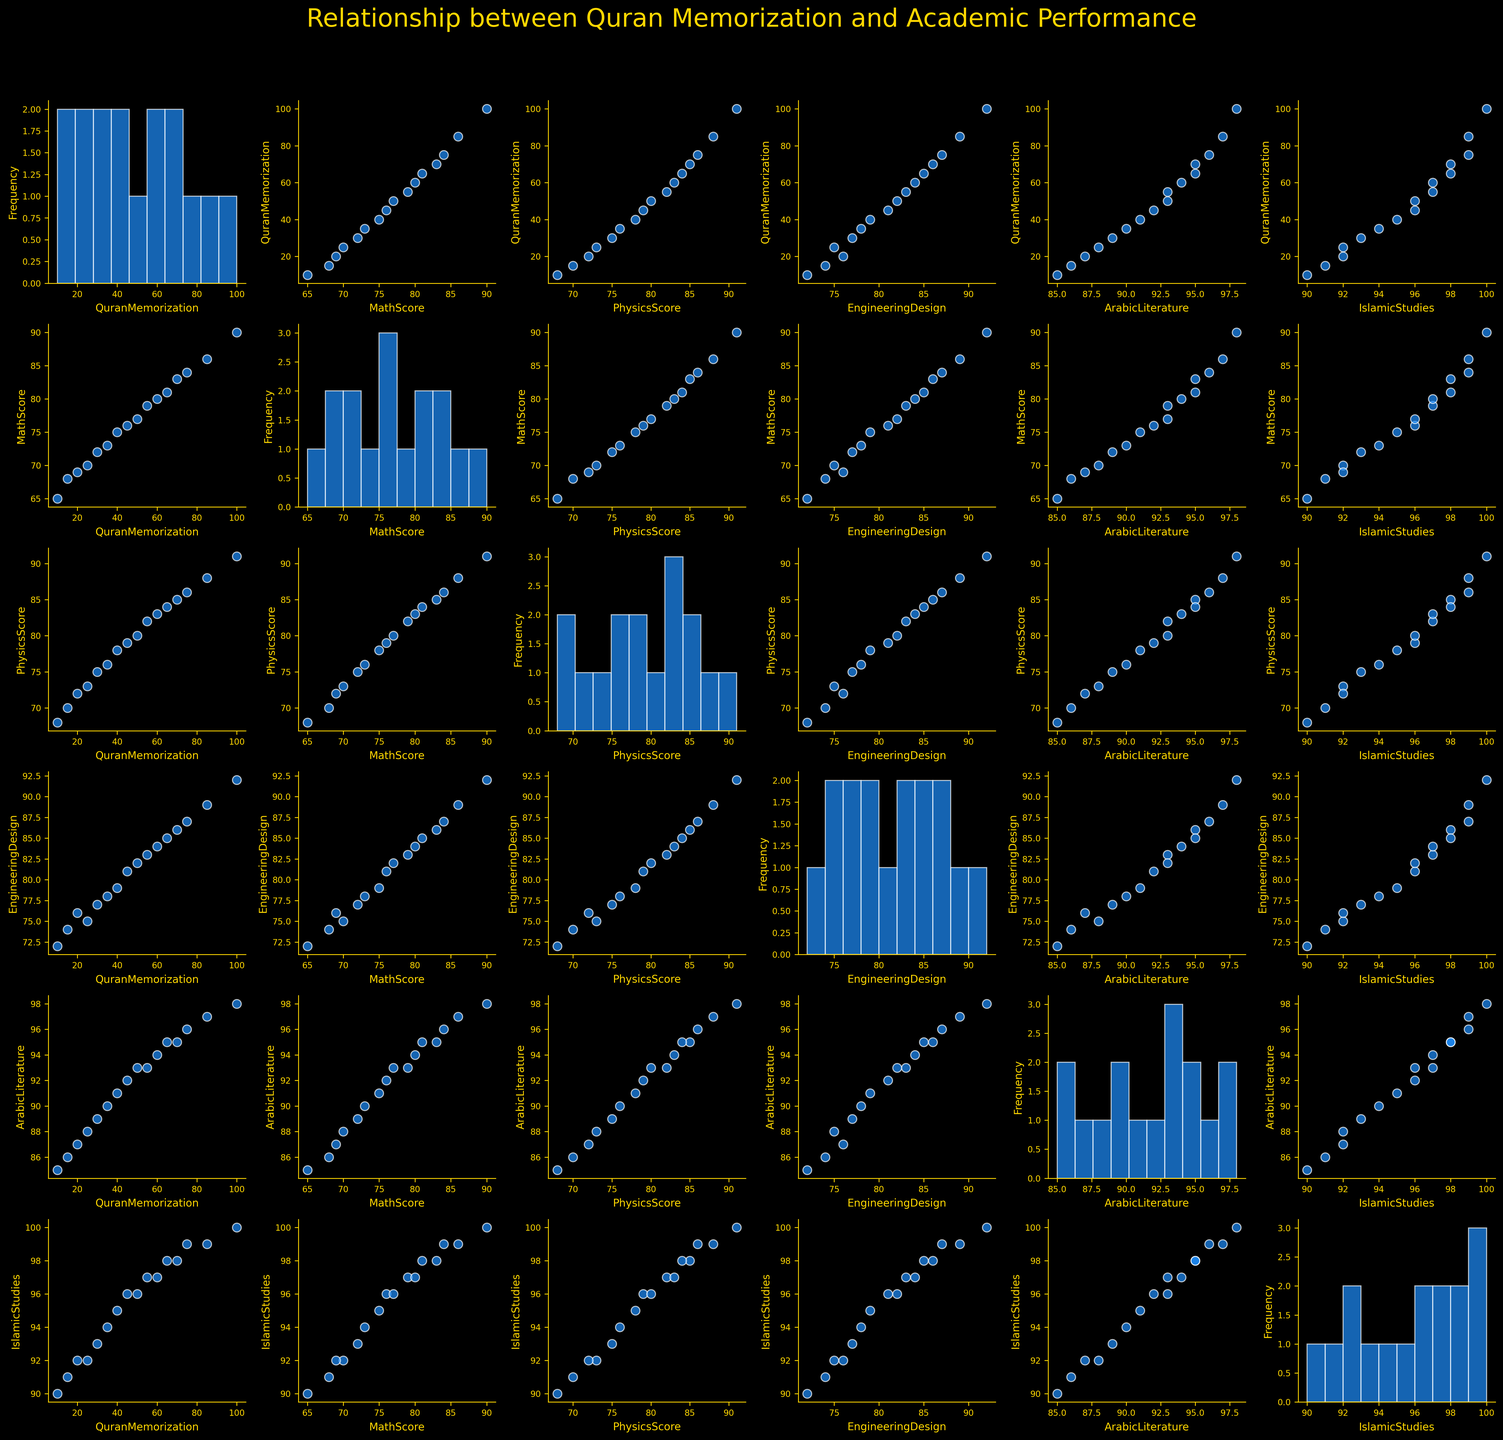What's the title of the plot? The title is displayed at the top of the figure. It reads "Relationship between Quran Memorization and Academic Performance".
Answer: Relationship between Quran Memorization and Academic Performance Which subject has the highest average score? You need to look at the scatter plots and histogram distributions of scores for all subjects. By comparing these, you can see that "Islamic Studies" consistently has the highest scores.
Answer: Islamic Studies Are the data points color-coded? Observing the scatter plots, you can see that all data points are of the same color, specifically blue with white edges.
Answer: No How many data points are there in each scatter plot? Each scatter plot is generated from the same dataset with 16 data points. You can count the number of points in any scatter plot to confirm.
Answer: 16 Is there a visible trend between Quran Memorization and Arabic Literature scores? By observing the scatter plot comparing Quran Memorization and Arabic Literature scores, you can see a positive trend, indicating that as Quran Memorization increases, Arabic Literature scores also tend to increase.
Answer: Yes Which two subjects show the highest correlation in scores? You can look at varying scatter plots to compare the linear relationships between different subjects. "Islamic Studies" and "Arabic Literature" appear to correlate highly based on their scatter plot.
Answer: Islamic Studies and Arabic Literature Does memorizing more Quran generally correspond to higher academic performance across all subjects? By observing multiple scatter plots where Quran Memorization is compared to different academic subjects, there is a general upward trend, indicating that increased Quran Memorization tends to correspond to higher academic performance.
Answer: Yes Between MathScore and PhysicsScore, which one shows a greater increase with Quran Memorization? By comparing the scatter plots of Quran Memorization vs. MathScore and Quran Memorization vs. PhysicsScore, both show an upward trend, but PhysicsScore seems to have a steeper slope, indicating a greater increase.
Answer: PhysicsScore Is the plot background dark or light? The entire plot has a dark background, as indicated by the dark styling applied to the figure.
Answer: Dark Which subject has the least variation in scores? Looking at the histograms along the diagonal, "Islamic Studies" has a narrow distribution of scores, suggesting it has the least variation.
Answer: Islamic Studies 